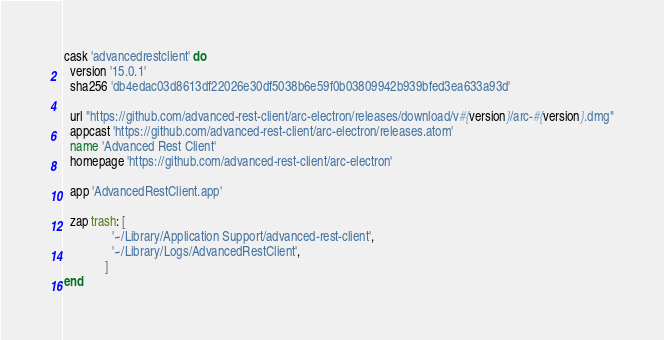<code> <loc_0><loc_0><loc_500><loc_500><_Ruby_>cask 'advancedrestclient' do
  version '15.0.1'
  sha256 'db4edac03d8613df22026e30df5038b6e59f0b03809942b939bfed3ea633a93d'

  url "https://github.com/advanced-rest-client/arc-electron/releases/download/v#{version}/arc-#{version}.dmg"
  appcast 'https://github.com/advanced-rest-client/arc-electron/releases.atom'
  name 'Advanced Rest Client'
  homepage 'https://github.com/advanced-rest-client/arc-electron'

  app 'AdvancedRestClient.app'

  zap trash: [
               '~/Library/Application Support/advanced-rest-client',
               '~/Library/Logs/AdvancedRestClient',
             ]
end
</code> 